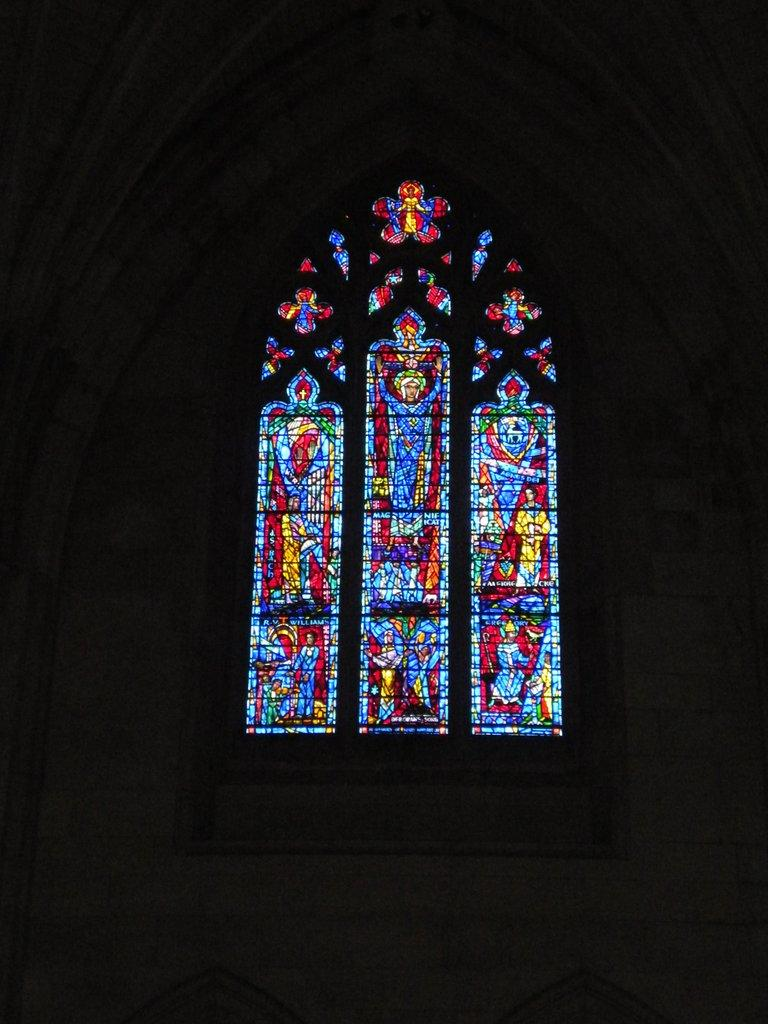What type of structure is present in the image? There is a glass window in the image. Can you describe the appearance of the glass window? The glass window has a colorful design. How many robins can be seen perched on the glass window in the image? There are no robins present in the image; it only features a glass window with a colorful design. 